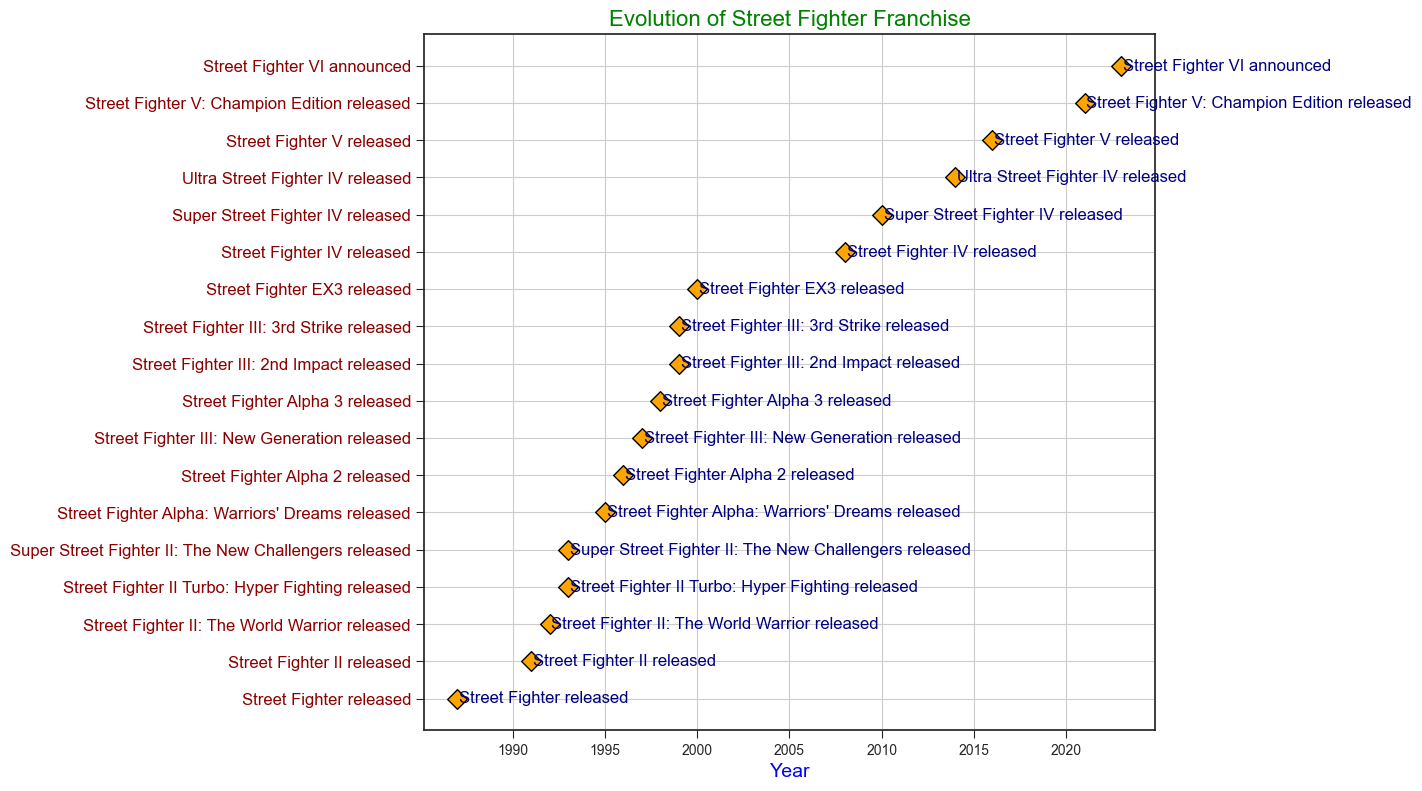What's the first game in Street Fighter franchise released? The first game in the dataset is listed as the earliest release in 1987 with the event "Street Fighter released."
Answer: Street Fighter Which games were released in the same year? By observing the plot, we can see two games listed for the year 1993: "Street Fighter II Turbo: Hyper Fighting" and "Super Street Fighter II: The New Challengers."
Answer: Street Fighter II Turbo: Hyper Fighting and Super Street Fighter II: The New Challengers What is the most recent event in the Street Fighter franchise? The event listed for the latest year, 2023, is "Street Fighter VI announced."
Answer: Street Fighter VI announced How many Street Fighter games were released in the 1990s? To count the releases in the 1990s, observe the events between 1990 and 1999. The listed years are 1991, 1992, 1993, 1993, 1995, 1996, 1997, 1998, and 1999 (twice). That's a total of 10 releases.
Answer: 10 Which game had the longest gap between it and the previous release date? By observing the years between each release, the longest gap appears between 2000 ("Street Fighter EX3 released") and 2008 ("Street Fighter IV released"), which is an 8-year gap.
Answer: Street Fighter EX3 and Street Fighter IV When did the shift from Street Fighter II to Street Fighter Alpha series occur? The last Street Fighter II game was released in 1993 ("Super Street Fighter II: The New Challengers") and the first Street Fighter Alpha game was released in 1995 ("Street Fighter Alpha: Warriors' Dreams").
Answer: 1993 to 1995 How many different updates of Street Fighter V are there? In the plot, two updates are noted: "Street Fighter V released" in 2016 and "Street Fighter V: Champion Edition" in 2021.
Answer: 2 Compare the number of games released between the 80s and the 2010s. Which decade had more releases? The 1980s had 1 release ("Street Fighter released" in 1987), and the 2010s had 3 releases ("Super Street Fighter IV" in 2010, "Ultra Street Fighter IV" in 2014, and "Street Fighter V" in 2016). The 2010s had more releases.
Answer: 2010s How frequent were new game releases in the Street Fighter franchise during the 90s compared to the 2000s? The 1990s had ten releases (1991 to 1999) and the 2000s had two releases (2000 and 2008). Thus, the 90s had more frequent releases.
Answer: 1990s In which periods were there rapid consecutive releases and what might it indicate? There are rapid consecutive releases between 1991-1993 and 1997-1999, each within contiguous years. This might indicate periods of high productivity or popularity in the franchise.
Answer: 1991-1993 and 1997-1999 